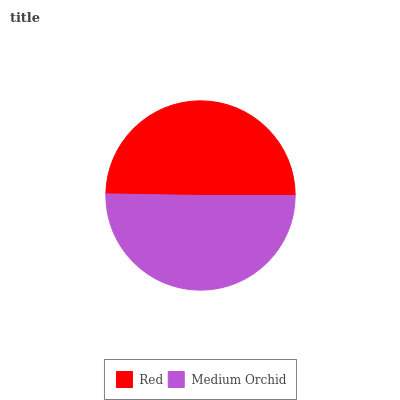Is Red the minimum?
Answer yes or no. Yes. Is Medium Orchid the maximum?
Answer yes or no. Yes. Is Medium Orchid the minimum?
Answer yes or no. No. Is Medium Orchid greater than Red?
Answer yes or no. Yes. Is Red less than Medium Orchid?
Answer yes or no. Yes. Is Red greater than Medium Orchid?
Answer yes or no. No. Is Medium Orchid less than Red?
Answer yes or no. No. Is Medium Orchid the high median?
Answer yes or no. Yes. Is Red the low median?
Answer yes or no. Yes. Is Red the high median?
Answer yes or no. No. Is Medium Orchid the low median?
Answer yes or no. No. 